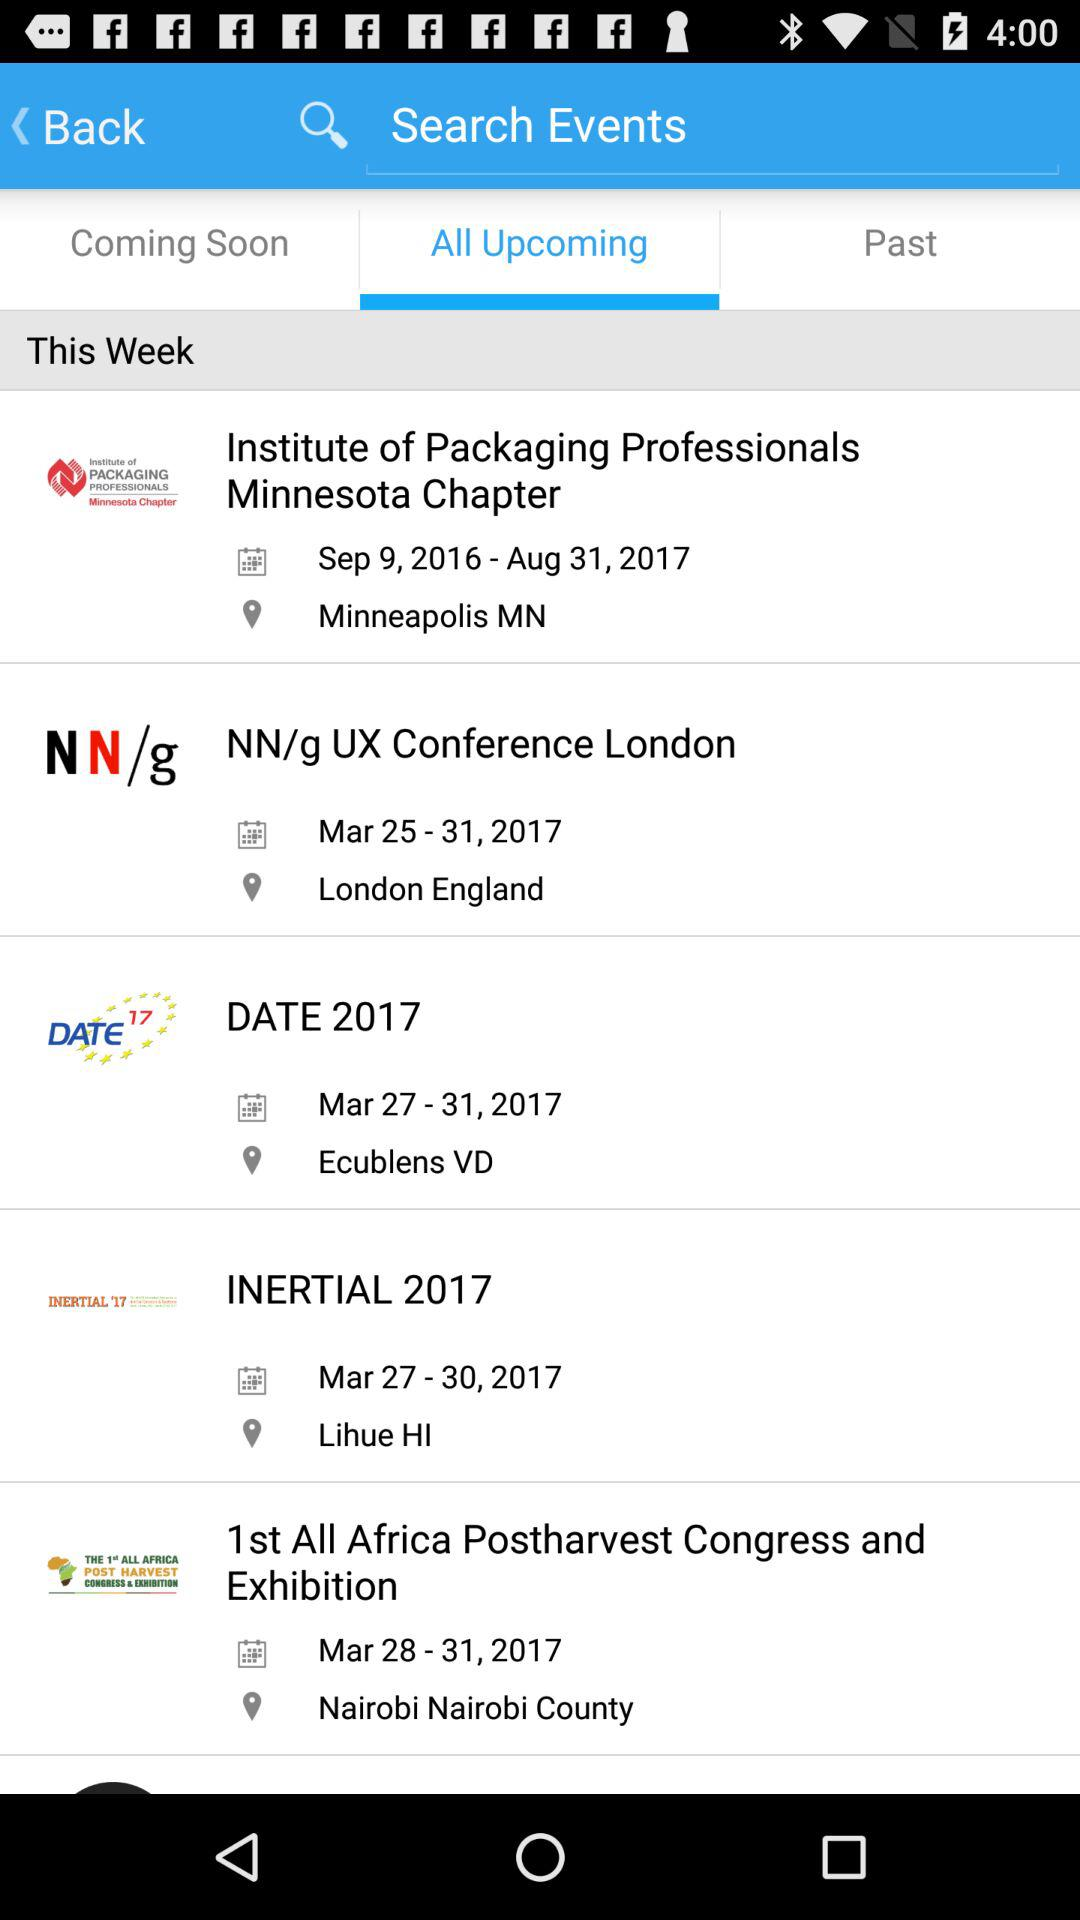What is the date range of "DATE 2017"? The date range is from March 27, 2017 to March 31, 2017. 